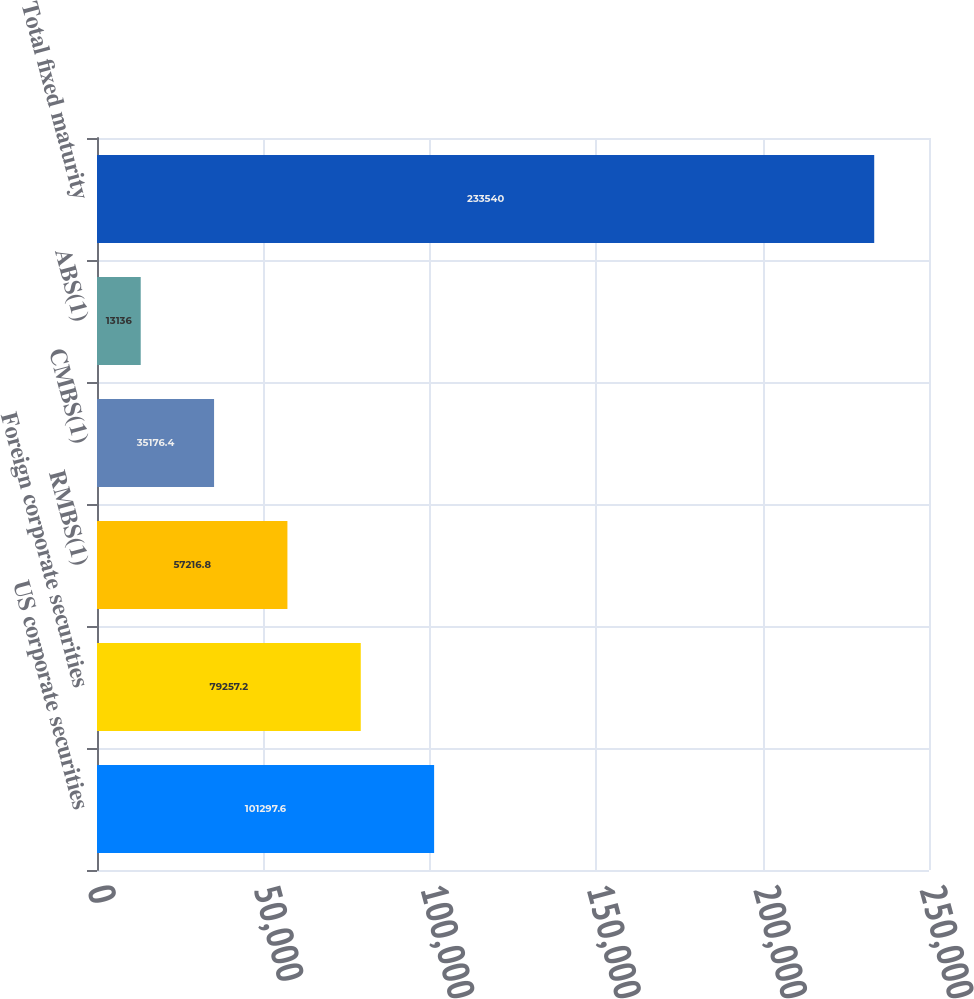Convert chart. <chart><loc_0><loc_0><loc_500><loc_500><bar_chart><fcel>US corporate securities<fcel>Foreign corporate securities<fcel>RMBS(1)<fcel>CMBS(1)<fcel>ABS(1)<fcel>Total fixed maturity<nl><fcel>101298<fcel>79257.2<fcel>57216.8<fcel>35176.4<fcel>13136<fcel>233540<nl></chart> 